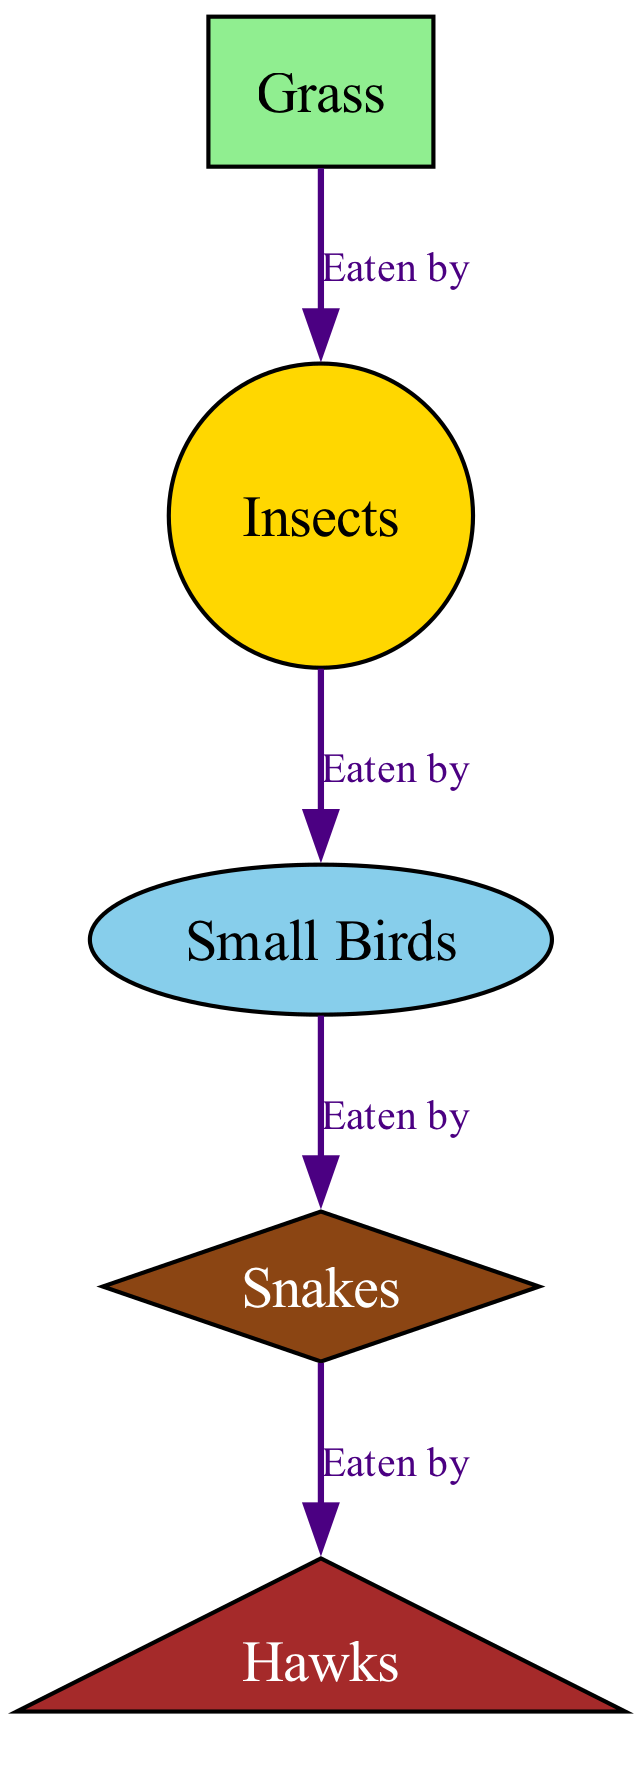What is the top node in this food chain? The top node in the food chain represents the highest level of the predator hierarchy. In this diagram, the top node is "Hawks," as it is not eaten by any other nodes.
Answer: Hawks How many nodes are in this diagram? To find the number of nodes, we count each unique entity represented in the diagram. There are five nodes: Grass, Insects, Small Birds, Snakes, and Hawks.
Answer: 5 What is eaten by Small Birds? The relationship indicated in the diagram shows that Small Birds eat Insects. This can be directly observed from the connecting edge labeled "Eaten by" between Small Birds and Insects.
Answer: Insects Which node is directly eaten by Snakes? Snakes are indicated to eat Small Birds as per the directed edge labeled "Eaten by." The relationship flows from Snakes to Small Birds in the sequence of predation.
Answer: Small Birds How many connections (edges) are in this diagram? The total number of connections is determined by counting how many "eaten by" relationships are present. There are four edges illustrated in this diagram, showing the flow from Grass to Hawks.
Answer: 4 What type of node is Grass? In the diagram, Grass is represented as a base producer, typically depicted using a rectangle shape. According to the node style attributes defined in the code, its characteristics are consistent with a primary food source in the chain.
Answer: Rectangle Which animal is at the highest level in this food chain? Looking at the hierarchy shown in the diagram, Hawks are at the highest level, as they prey on Snakes and are the only node not eaten by any others in the chain.
Answer: Hawks What is the relationship between Grass and Insects? The directed arrow demonstrates that Insects are the consumers of Grass, showing that Grass is the food source for Insects. The label "Eaten by" explains this relationship clearly.
Answer: Eaten by Which creature is not a predator in this food chain? By analyzing the roles of each node, Grass is recognized as a primary producer and not a predator, since it is eaten by Insects rather than consuming any other creature.
Answer: Grass 